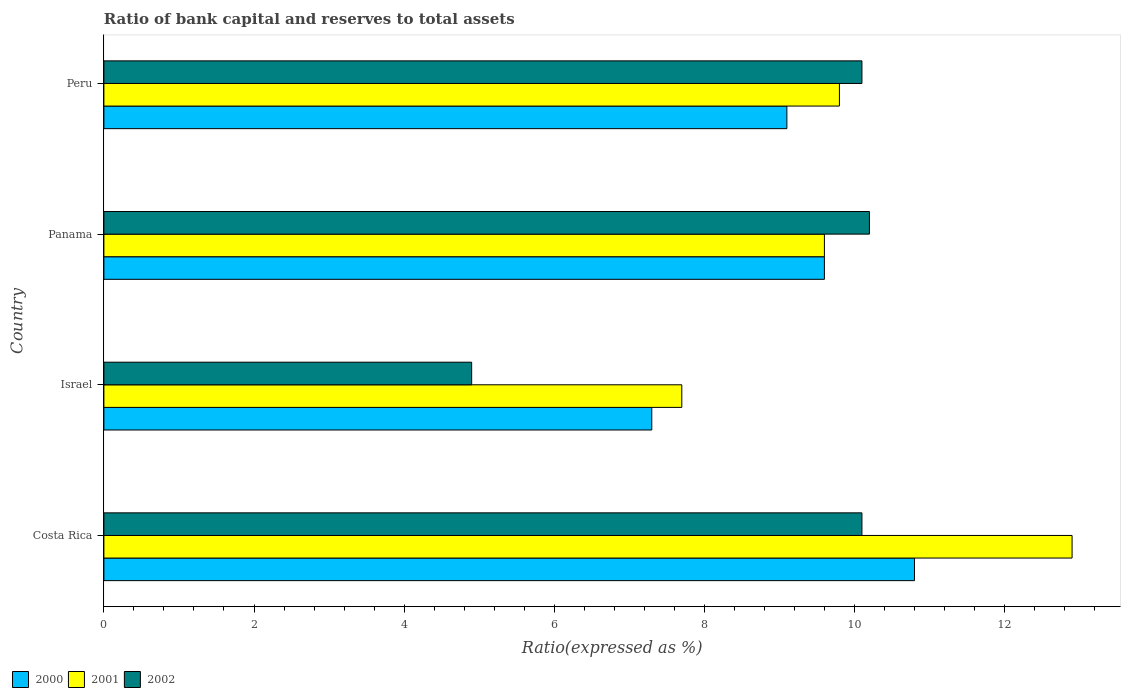How many different coloured bars are there?
Ensure brevity in your answer.  3. How many groups of bars are there?
Give a very brief answer. 4. Are the number of bars on each tick of the Y-axis equal?
Your answer should be very brief. Yes. How many bars are there on the 2nd tick from the top?
Offer a very short reply. 3. What is the label of the 2nd group of bars from the top?
Give a very brief answer. Panama. In how many cases, is the number of bars for a given country not equal to the number of legend labels?
Your response must be concise. 0. What is the ratio of bank capital and reserves to total assets in 2001 in Panama?
Make the answer very short. 9.6. Across all countries, what is the maximum ratio of bank capital and reserves to total assets in 2001?
Offer a terse response. 12.9. Across all countries, what is the minimum ratio of bank capital and reserves to total assets in 2001?
Provide a short and direct response. 7.7. In which country was the ratio of bank capital and reserves to total assets in 2002 maximum?
Keep it short and to the point. Panama. In which country was the ratio of bank capital and reserves to total assets in 2000 minimum?
Offer a very short reply. Israel. What is the total ratio of bank capital and reserves to total assets in 2002 in the graph?
Provide a succinct answer. 35.3. What is the difference between the ratio of bank capital and reserves to total assets in 2000 in Costa Rica and that in Peru?
Your response must be concise. 1.7. What is the average ratio of bank capital and reserves to total assets in 2002 per country?
Keep it short and to the point. 8.82. What is the difference between the ratio of bank capital and reserves to total assets in 2002 and ratio of bank capital and reserves to total assets in 2001 in Panama?
Your answer should be compact. 0.6. What is the ratio of the ratio of bank capital and reserves to total assets in 2000 in Panama to that in Peru?
Keep it short and to the point. 1.05. Is the ratio of bank capital and reserves to total assets in 2002 in Costa Rica less than that in Israel?
Give a very brief answer. No. What is the difference between the highest and the second highest ratio of bank capital and reserves to total assets in 2001?
Make the answer very short. 3.1. What is the difference between the highest and the lowest ratio of bank capital and reserves to total assets in 2001?
Ensure brevity in your answer.  5.2. Is the sum of the ratio of bank capital and reserves to total assets in 2002 in Costa Rica and Israel greater than the maximum ratio of bank capital and reserves to total assets in 2000 across all countries?
Your answer should be compact. Yes. What does the 1st bar from the bottom in Israel represents?
Ensure brevity in your answer.  2000. Is it the case that in every country, the sum of the ratio of bank capital and reserves to total assets in 2002 and ratio of bank capital and reserves to total assets in 2000 is greater than the ratio of bank capital and reserves to total assets in 2001?
Offer a very short reply. Yes. How many bars are there?
Make the answer very short. 12. What is the difference between two consecutive major ticks on the X-axis?
Your response must be concise. 2. Does the graph contain any zero values?
Offer a terse response. No. How many legend labels are there?
Provide a short and direct response. 3. How are the legend labels stacked?
Provide a short and direct response. Horizontal. What is the title of the graph?
Keep it short and to the point. Ratio of bank capital and reserves to total assets. What is the label or title of the X-axis?
Make the answer very short. Ratio(expressed as %). What is the label or title of the Y-axis?
Keep it short and to the point. Country. What is the Ratio(expressed as %) in 2000 in Costa Rica?
Give a very brief answer. 10.8. What is the Ratio(expressed as %) in 2002 in Costa Rica?
Ensure brevity in your answer.  10.1. What is the Ratio(expressed as %) in 2000 in Panama?
Make the answer very short. 9.6. What is the Ratio(expressed as %) of 2001 in Panama?
Your answer should be compact. 9.6. What is the Ratio(expressed as %) in 2002 in Panama?
Give a very brief answer. 10.2. What is the Ratio(expressed as %) in 2000 in Peru?
Offer a very short reply. 9.1. What is the Ratio(expressed as %) in 2002 in Peru?
Provide a short and direct response. 10.1. Across all countries, what is the minimum Ratio(expressed as %) of 2000?
Ensure brevity in your answer.  7.3. What is the total Ratio(expressed as %) in 2000 in the graph?
Your answer should be very brief. 36.8. What is the total Ratio(expressed as %) of 2002 in the graph?
Offer a very short reply. 35.3. What is the difference between the Ratio(expressed as %) of 2001 in Costa Rica and that in Israel?
Offer a terse response. 5.2. What is the difference between the Ratio(expressed as %) in 2002 in Costa Rica and that in Israel?
Offer a terse response. 5.2. What is the difference between the Ratio(expressed as %) of 2002 in Costa Rica and that in Panama?
Your response must be concise. -0.1. What is the difference between the Ratio(expressed as %) in 2001 in Costa Rica and that in Peru?
Provide a succinct answer. 3.1. What is the difference between the Ratio(expressed as %) of 2002 in Israel and that in Panama?
Your response must be concise. -5.3. What is the difference between the Ratio(expressed as %) of 2000 in Israel and that in Peru?
Your answer should be compact. -1.8. What is the difference between the Ratio(expressed as %) of 2001 in Israel and that in Peru?
Provide a short and direct response. -2.1. What is the difference between the Ratio(expressed as %) in 2002 in Israel and that in Peru?
Your answer should be very brief. -5.2. What is the difference between the Ratio(expressed as %) in 2002 in Panama and that in Peru?
Offer a very short reply. 0.1. What is the difference between the Ratio(expressed as %) of 2000 in Costa Rica and the Ratio(expressed as %) of 2002 in Israel?
Your answer should be very brief. 5.9. What is the difference between the Ratio(expressed as %) of 2000 in Costa Rica and the Ratio(expressed as %) of 2001 in Panama?
Give a very brief answer. 1.2. What is the difference between the Ratio(expressed as %) in 2000 in Costa Rica and the Ratio(expressed as %) in 2002 in Panama?
Offer a very short reply. 0.6. What is the difference between the Ratio(expressed as %) of 2001 in Costa Rica and the Ratio(expressed as %) of 2002 in Panama?
Make the answer very short. 2.7. What is the difference between the Ratio(expressed as %) in 2000 in Costa Rica and the Ratio(expressed as %) in 2001 in Peru?
Offer a very short reply. 1. What is the difference between the Ratio(expressed as %) of 2001 in Costa Rica and the Ratio(expressed as %) of 2002 in Peru?
Provide a short and direct response. 2.8. What is the difference between the Ratio(expressed as %) of 2000 in Israel and the Ratio(expressed as %) of 2001 in Peru?
Give a very brief answer. -2.5. What is the difference between the Ratio(expressed as %) in 2000 in Israel and the Ratio(expressed as %) in 2002 in Peru?
Offer a very short reply. -2.8. What is the difference between the Ratio(expressed as %) of 2001 in Israel and the Ratio(expressed as %) of 2002 in Peru?
Ensure brevity in your answer.  -2.4. What is the difference between the Ratio(expressed as %) of 2001 in Panama and the Ratio(expressed as %) of 2002 in Peru?
Offer a very short reply. -0.5. What is the average Ratio(expressed as %) of 2000 per country?
Your answer should be very brief. 9.2. What is the average Ratio(expressed as %) in 2002 per country?
Make the answer very short. 8.82. What is the difference between the Ratio(expressed as %) of 2001 and Ratio(expressed as %) of 2002 in Costa Rica?
Your answer should be compact. 2.8. What is the difference between the Ratio(expressed as %) in 2000 and Ratio(expressed as %) in 2001 in Panama?
Make the answer very short. 0. What is the difference between the Ratio(expressed as %) in 2000 and Ratio(expressed as %) in 2002 in Panama?
Ensure brevity in your answer.  -0.6. What is the difference between the Ratio(expressed as %) of 2001 and Ratio(expressed as %) of 2002 in Panama?
Keep it short and to the point. -0.6. What is the difference between the Ratio(expressed as %) in 2000 and Ratio(expressed as %) in 2001 in Peru?
Provide a short and direct response. -0.7. What is the difference between the Ratio(expressed as %) in 2000 and Ratio(expressed as %) in 2002 in Peru?
Provide a succinct answer. -1. What is the ratio of the Ratio(expressed as %) in 2000 in Costa Rica to that in Israel?
Your response must be concise. 1.48. What is the ratio of the Ratio(expressed as %) of 2001 in Costa Rica to that in Israel?
Your response must be concise. 1.68. What is the ratio of the Ratio(expressed as %) in 2002 in Costa Rica to that in Israel?
Keep it short and to the point. 2.06. What is the ratio of the Ratio(expressed as %) in 2000 in Costa Rica to that in Panama?
Your answer should be very brief. 1.12. What is the ratio of the Ratio(expressed as %) in 2001 in Costa Rica to that in Panama?
Offer a terse response. 1.34. What is the ratio of the Ratio(expressed as %) in 2002 in Costa Rica to that in Panama?
Keep it short and to the point. 0.99. What is the ratio of the Ratio(expressed as %) in 2000 in Costa Rica to that in Peru?
Make the answer very short. 1.19. What is the ratio of the Ratio(expressed as %) in 2001 in Costa Rica to that in Peru?
Ensure brevity in your answer.  1.32. What is the ratio of the Ratio(expressed as %) in 2000 in Israel to that in Panama?
Offer a terse response. 0.76. What is the ratio of the Ratio(expressed as %) of 2001 in Israel to that in Panama?
Ensure brevity in your answer.  0.8. What is the ratio of the Ratio(expressed as %) of 2002 in Israel to that in Panama?
Your answer should be very brief. 0.48. What is the ratio of the Ratio(expressed as %) in 2000 in Israel to that in Peru?
Make the answer very short. 0.8. What is the ratio of the Ratio(expressed as %) in 2001 in Israel to that in Peru?
Offer a terse response. 0.79. What is the ratio of the Ratio(expressed as %) of 2002 in Israel to that in Peru?
Offer a very short reply. 0.49. What is the ratio of the Ratio(expressed as %) in 2000 in Panama to that in Peru?
Your answer should be very brief. 1.05. What is the ratio of the Ratio(expressed as %) of 2001 in Panama to that in Peru?
Make the answer very short. 0.98. What is the ratio of the Ratio(expressed as %) in 2002 in Panama to that in Peru?
Offer a terse response. 1.01. What is the difference between the highest and the second highest Ratio(expressed as %) of 2000?
Make the answer very short. 1.2. What is the difference between the highest and the second highest Ratio(expressed as %) in 2002?
Offer a very short reply. 0.1. What is the difference between the highest and the lowest Ratio(expressed as %) of 2002?
Provide a short and direct response. 5.3. 